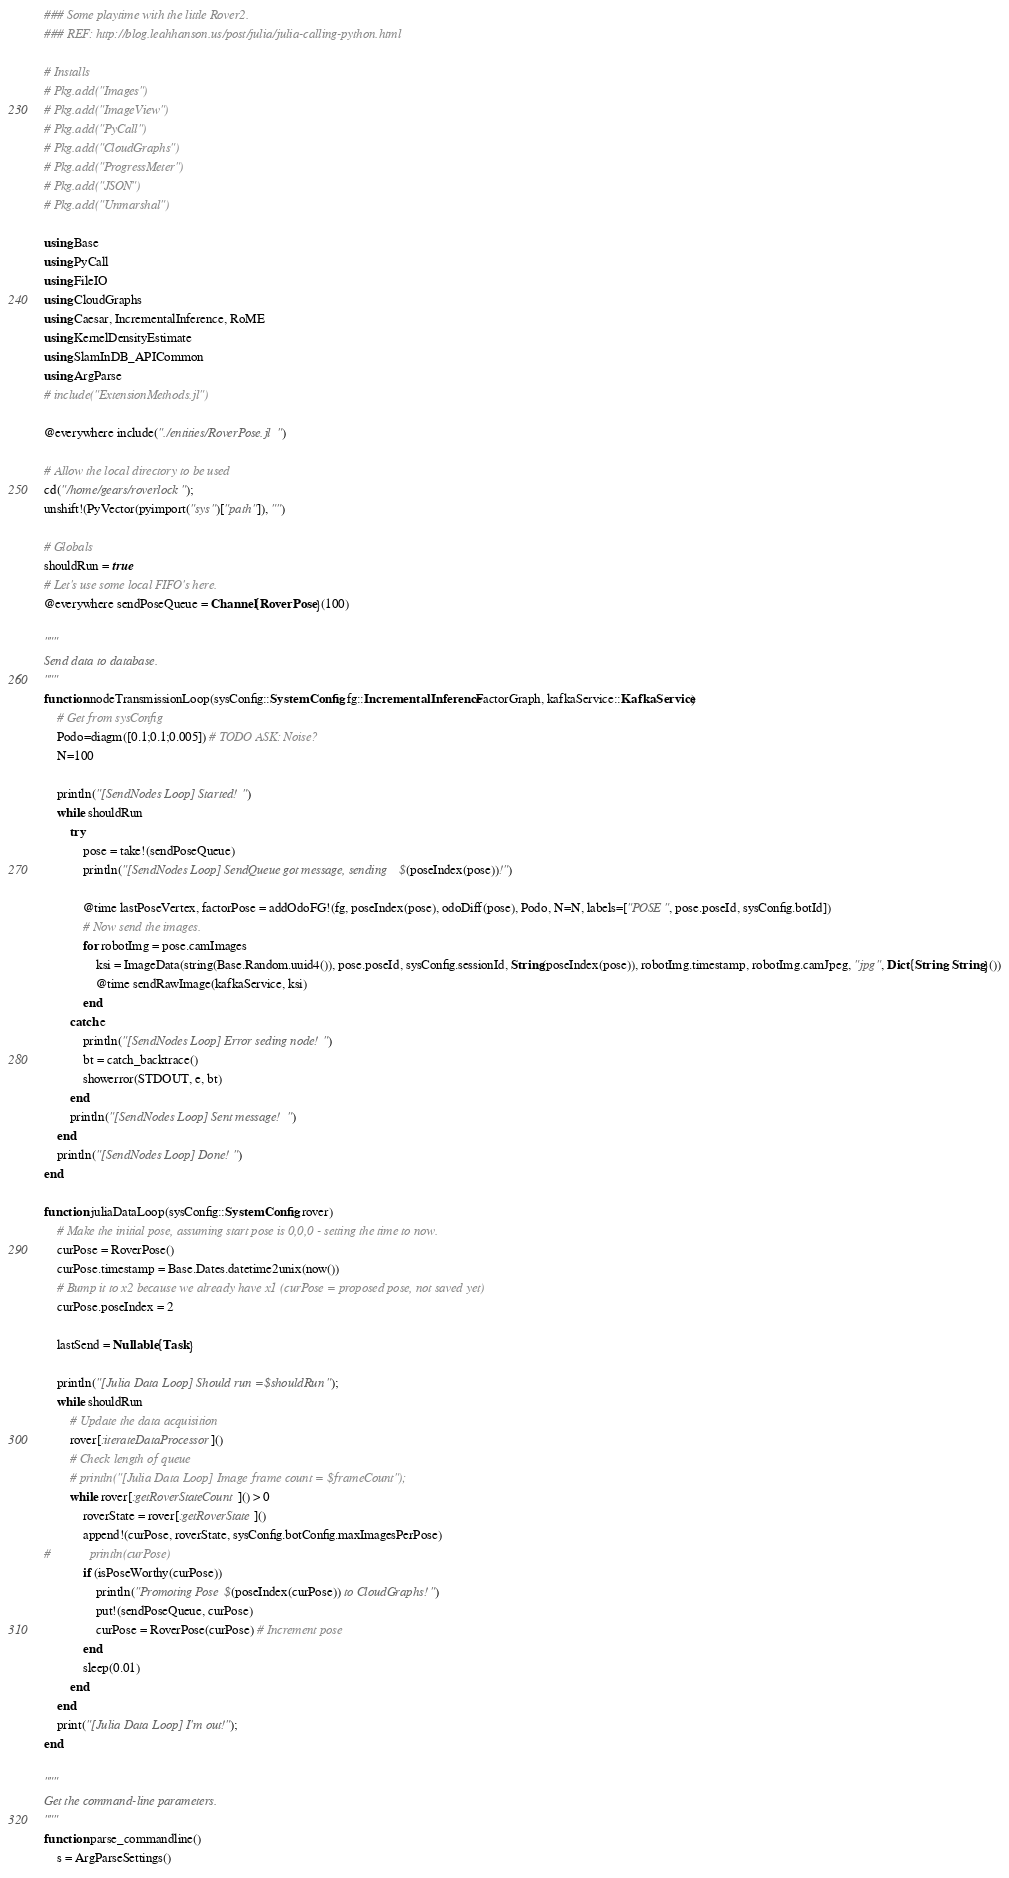<code> <loc_0><loc_0><loc_500><loc_500><_Julia_>### Some playtime with the little Rover2.
### REF: http://blog.leahhanson.us/post/julia/julia-calling-python.html

# Installs
# Pkg.add("Images")
# Pkg.add("ImageView")
# Pkg.add("PyCall")
# Pkg.add("CloudGraphs")
# Pkg.add("ProgressMeter")
# Pkg.add("JSON")
# Pkg.add("Unmarshal")

using Base
using PyCall
using FileIO
using CloudGraphs
using Caesar, IncrementalInference, RoME
using KernelDensityEstimate
using SlamInDB_APICommon
using ArgParse
# include("ExtensionMethods.jl")

@everywhere include("./entities/RoverPose.jl")

# Allow the local directory to be used
cd("/home/gears/roverlock");
unshift!(PyVector(pyimport("sys")["path"]), "")

# Globals
shouldRun = true
# Let's use some local FIFO's here.
@everywhere sendPoseQueue = Channel{RoverPose}(100)

"""
Send data to database.
"""
function nodeTransmissionLoop(sysConfig::SystemConfig, fg::IncrementalInference.FactorGraph, kafkaService::KafkaService)
    # Get from sysConfig
    Podo=diagm([0.1;0.1;0.005]) # TODO ASK: Noise?
    N=100

    println("[SendNodes Loop] Started!")
    while shouldRun
        try
            pose = take!(sendPoseQueue)
            println("[SendNodes Loop] SendQueue got message, sending $(poseIndex(pose))!")

            @time lastPoseVertex, factorPose = addOdoFG!(fg, poseIndex(pose), odoDiff(pose), Podo, N=N, labels=["POSE", pose.poseId, sysConfig.botId])
            # Now send the images.
            for robotImg = pose.camImages
                ksi = ImageData(string(Base.Random.uuid4()), pose.poseId, sysConfig.sessionId, String(poseIndex(pose)), robotImg.timestamp, robotImg.camJpeg, "jpg", Dict{String, String}())
                @time sendRawImage(kafkaService, ksi)
            end
        catch e
            println("[SendNodes Loop] Error seding node!")
            bt = catch_backtrace()
            showerror(STDOUT, e, bt)
        end
        println("[SendNodes Loop] Sent message!")
    end
    println("[SendNodes Loop] Done!")
end

function juliaDataLoop(sysConfig::SystemConfig, rover)
    # Make the initial pose, assuming start pose is 0,0,0 - setting the time to now.
    curPose = RoverPose()
    curPose.timestamp = Base.Dates.datetime2unix(now())
    # Bump it to x2 because we already have x1 (curPose = proposed pose, not saved yet)
    curPose.poseIndex = 2

    lastSend = Nullable{Task}

    println("[Julia Data Loop] Should run = $shouldRun");
    while shouldRun
        # Update the data acquisition
        rover[:iterateDataProcessor]()
        # Check length of queue
        # println("[Julia Data Loop] Image frame count = $frameCount");
        while rover[:getRoverStateCount]() > 0
            roverState = rover[:getRoverState]()
            append!(curPose, roverState, sysConfig.botConfig.maxImagesPerPose)
#            println(curPose)
            if (isPoseWorthy(curPose))
                println("Promoting Pose $(poseIndex(curPose)) to CloudGraphs!")
                put!(sendPoseQueue, curPose)
                curPose = RoverPose(curPose) # Increment pose
            end
            sleep(0.01)
        end
    end
    print("[Julia Data Loop] I'm out!");
end

"""
Get the command-line parameters.
"""
function parse_commandline()
    s = ArgParseSettings()
</code> 